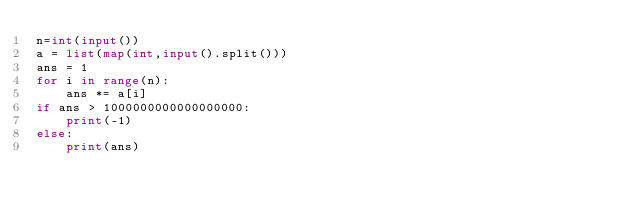<code> <loc_0><loc_0><loc_500><loc_500><_Python_>n=int(input())
a = list(map(int,input().split()))
ans = 1
for i in range(n):
    ans *= a[i]
if ans > 1000000000000000000:
    print(-1)
else:
    print(ans)</code> 